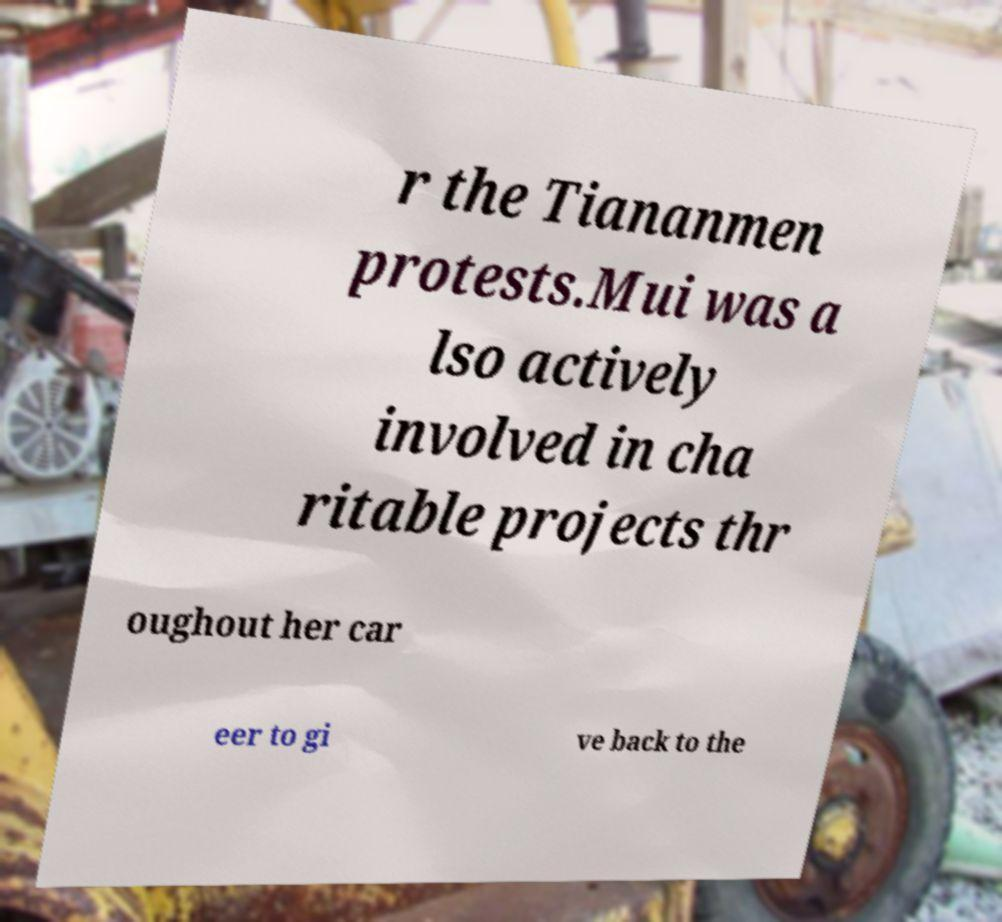Please read and relay the text visible in this image. What does it say? r the Tiananmen protests.Mui was a lso actively involved in cha ritable projects thr oughout her car eer to gi ve back to the 